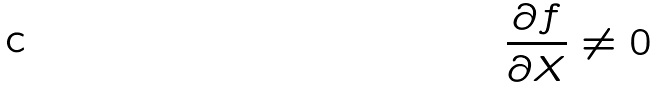Convert formula to latex. <formula><loc_0><loc_0><loc_500><loc_500>\frac { \partial f } { \partial X } \ne 0</formula> 